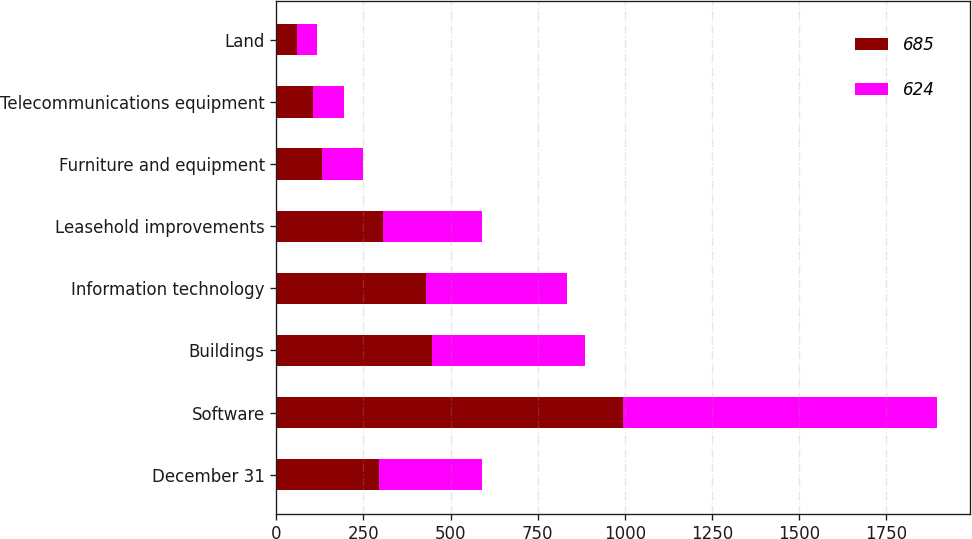<chart> <loc_0><loc_0><loc_500><loc_500><stacked_bar_chart><ecel><fcel>December 31<fcel>Software<fcel>Buildings<fcel>Information technology<fcel>Leasehold improvements<fcel>Furniture and equipment<fcel>Telecommunications equipment<fcel>Land<nl><fcel>685<fcel>294.5<fcel>993<fcel>446<fcel>430<fcel>307<fcel>131<fcel>104<fcel>59<nl><fcel>624<fcel>294.5<fcel>902<fcel>438<fcel>405<fcel>282<fcel>118<fcel>91<fcel>57<nl></chart> 